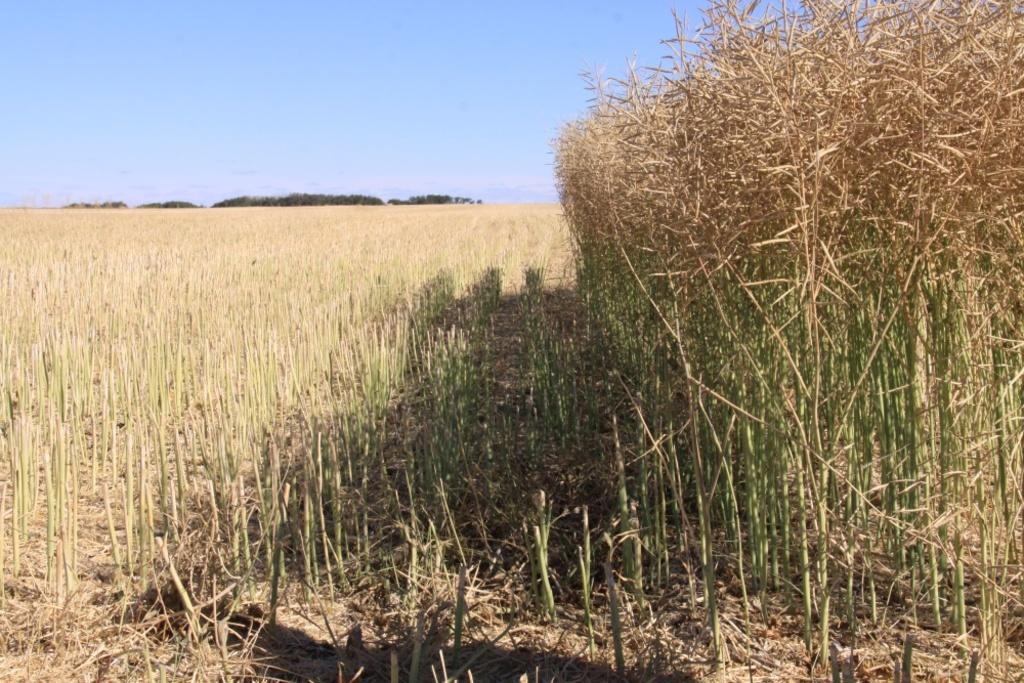What type of living organisms can be seen in the image? Plants can be seen in the image. How many brothers are singing together in the image? There are no brothers or songs present in the image; it only features plants. What type of lamp is illuminating the plants in the image? There is no lamp present in the image; it only features plants. 